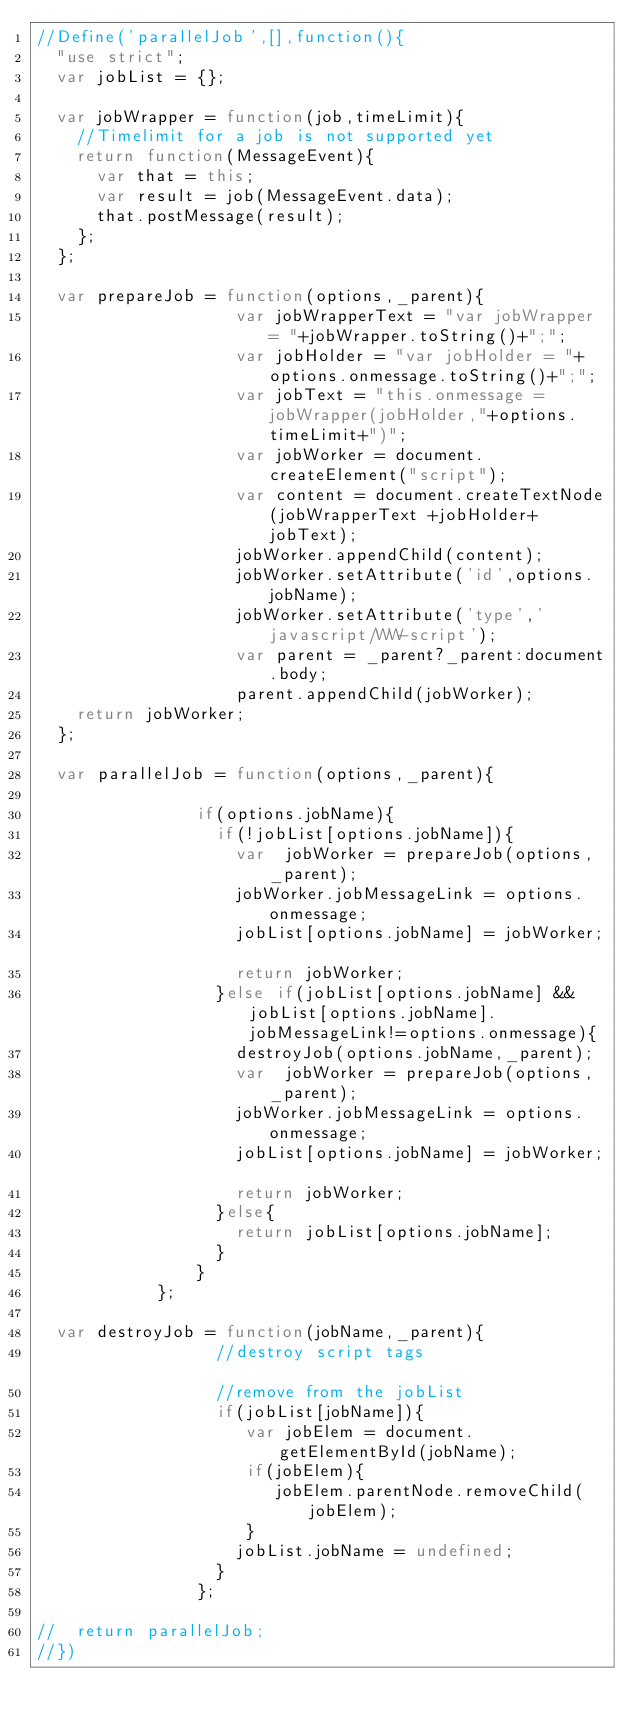Convert code to text. <code><loc_0><loc_0><loc_500><loc_500><_JavaScript_>//Define('parallelJob',[],function(){
	"use strict";
	var jobList = {};

	var jobWrapper = function(job,timeLimit){
		//Timelimit for a job is not supported yet
		return function(MessageEvent){	
			var that = this;
			var result = job(MessageEvent.data);
			that.postMessage(result);	
		};
	};

	var prepareJob = function(options,_parent){
										var jobWrapperText = "var jobWrapper = "+jobWrapper.toString()+";";
										var jobHolder = "var jobHolder = "+options.onmessage.toString()+";";
										var jobText = "this.onmessage =jobWrapper(jobHolder,"+options.timeLimit+")";
										var jobWorker = document.createElement("script");
										var content = document.createTextNode(jobWrapperText +jobHolder+ jobText);
										jobWorker.appendChild(content);
										jobWorker.setAttribute('id',options.jobName);
										jobWorker.setAttribute('type','javascript/WW-script');
										var parent = _parent?_parent:document.body;
										parent.appendChild(jobWorker);
		return jobWorker;
	};
	
	var parallelJob = function(options,_parent){
																		
								if(options.jobName){
									if(!jobList[options.jobName]){
										var  jobWorker = prepareJob(options,_parent);
										jobWorker.jobMessageLink = options.onmessage;
										jobList[options.jobName] = jobWorker;										
										return jobWorker;
									}else if(jobList[options.jobName] && jobList[options.jobName].jobMessageLink!=options.onmessage){
										destroyJob(options.jobName,_parent);
										var  jobWorker = prepareJob(options,_parent);
										jobWorker.jobMessageLink = options.onmessage;
										jobList[options.jobName] = jobWorker;										
										return jobWorker;
									}else{
										return jobList[options.jobName];
									}
								}
						};
						
	var destroyJob = function(jobName,_parent){
									//destroy script tags										
									//remove from the jobList 
									if(jobList[jobName]){
										 var jobElem = document.getElementById(jobName);
										 if(jobElem){
												jobElem.parentNode.removeChild(jobElem);
										 }
										jobList.jobName = undefined;
									}
								};
						
//	return parallelJob;
//})
</code> 